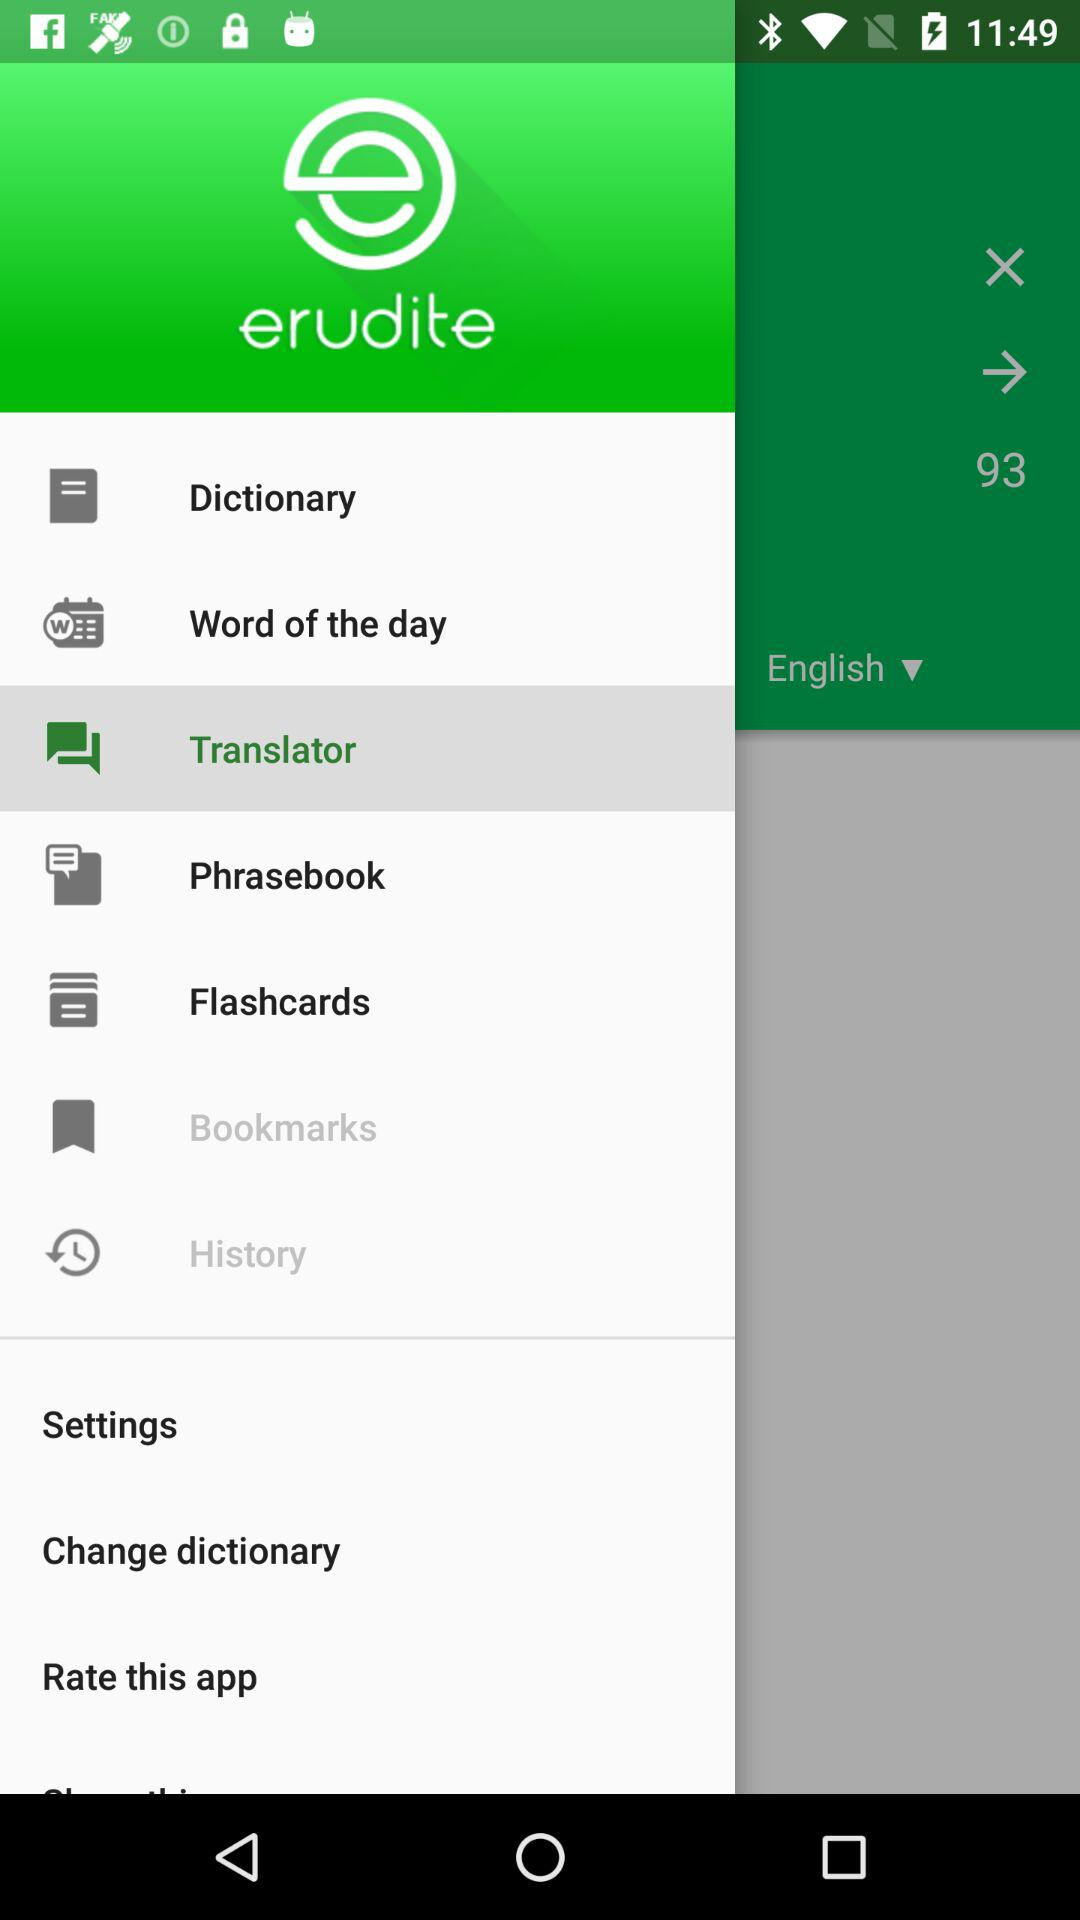What’s the app name? The app name is "erudite". 